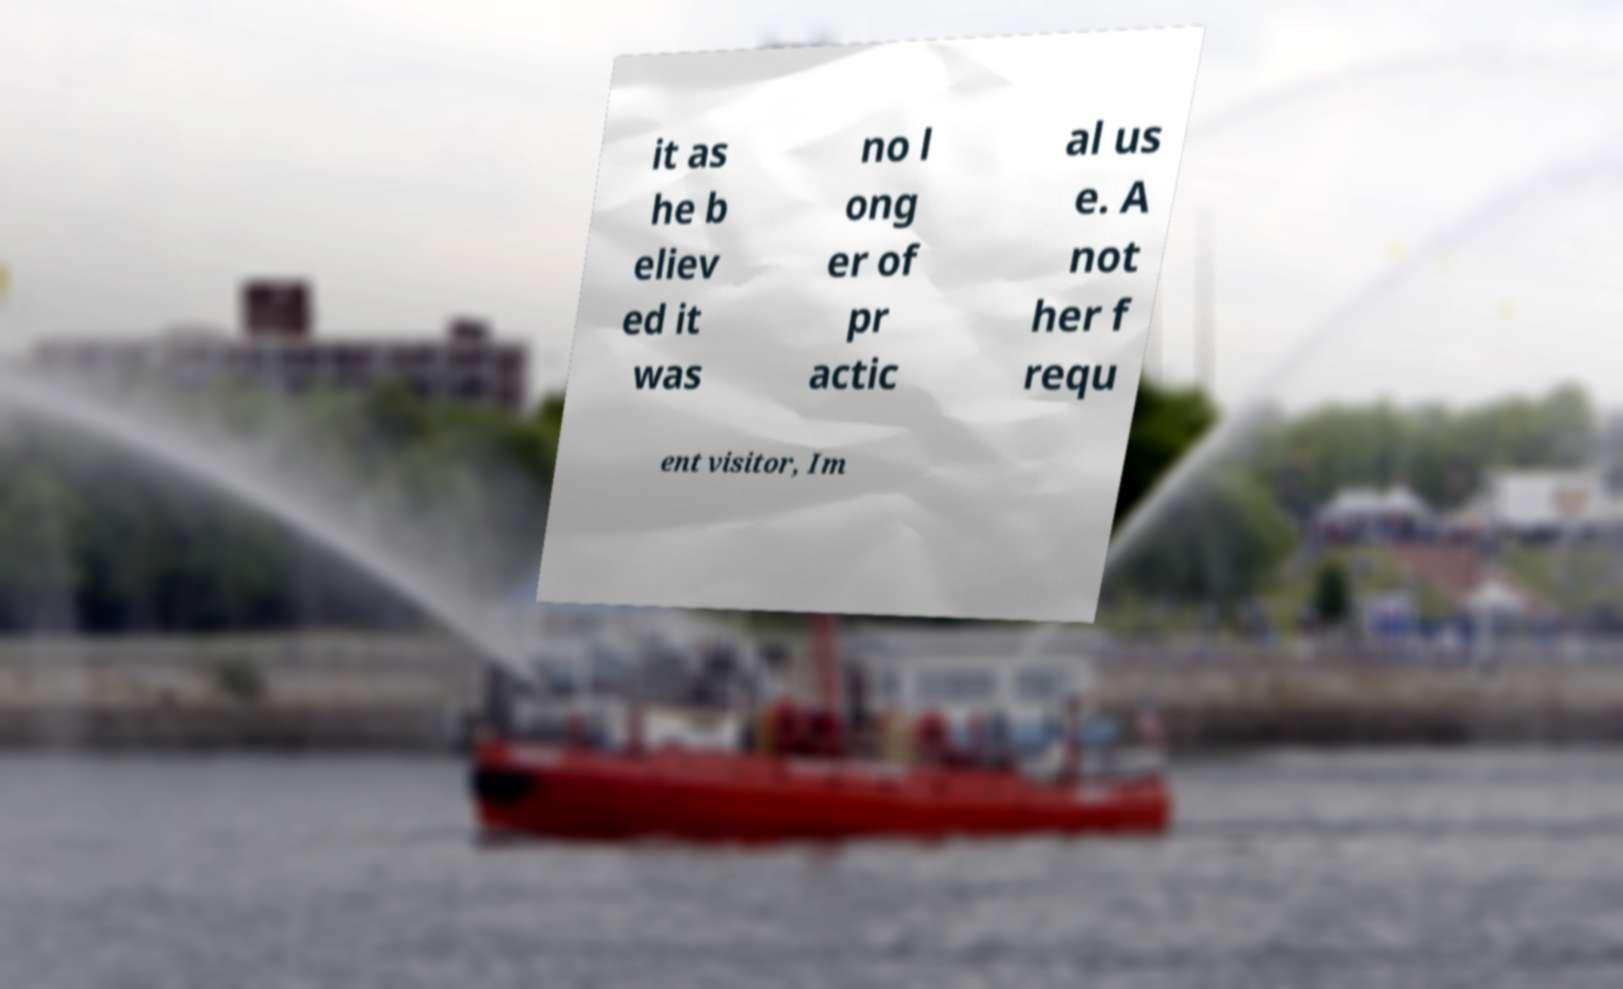There's text embedded in this image that I need extracted. Can you transcribe it verbatim? it as he b eliev ed it was no l ong er of pr actic al us e. A not her f requ ent visitor, Im 